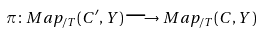<formula> <loc_0><loc_0><loc_500><loc_500>\pi \colon M a p _ { / T } ( C ^ { \prime } , Y ) \longrightarrow M a p _ { / T } ( C , Y )</formula> 